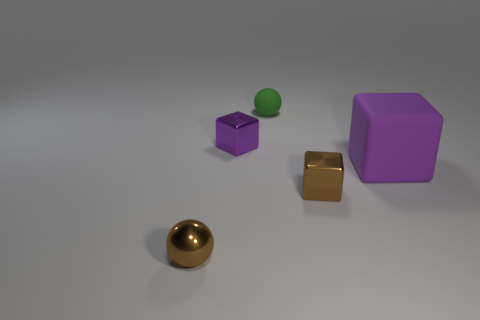What shape is the purple object that is made of the same material as the small green sphere?
Provide a short and direct response. Cube. Do the small purple object and the big rubber thing have the same shape?
Provide a succinct answer. Yes. The matte ball is what color?
Offer a terse response. Green. What number of things are rubber balls or large yellow matte objects?
Ensure brevity in your answer.  1. Are there fewer big purple cubes on the right side of the purple matte thing than large gray matte cubes?
Keep it short and to the point. No. Are there more matte things that are behind the tiny purple metallic object than tiny green matte spheres in front of the tiny green sphere?
Your answer should be compact. Yes. Are there any other things that are the same color as the big cube?
Offer a very short reply. Yes. There is a purple object on the right side of the tiny brown metal block; what is its material?
Ensure brevity in your answer.  Rubber. Is the size of the metallic sphere the same as the rubber cube?
Make the answer very short. No. What number of other objects are there of the same size as the green thing?
Keep it short and to the point. 3. 